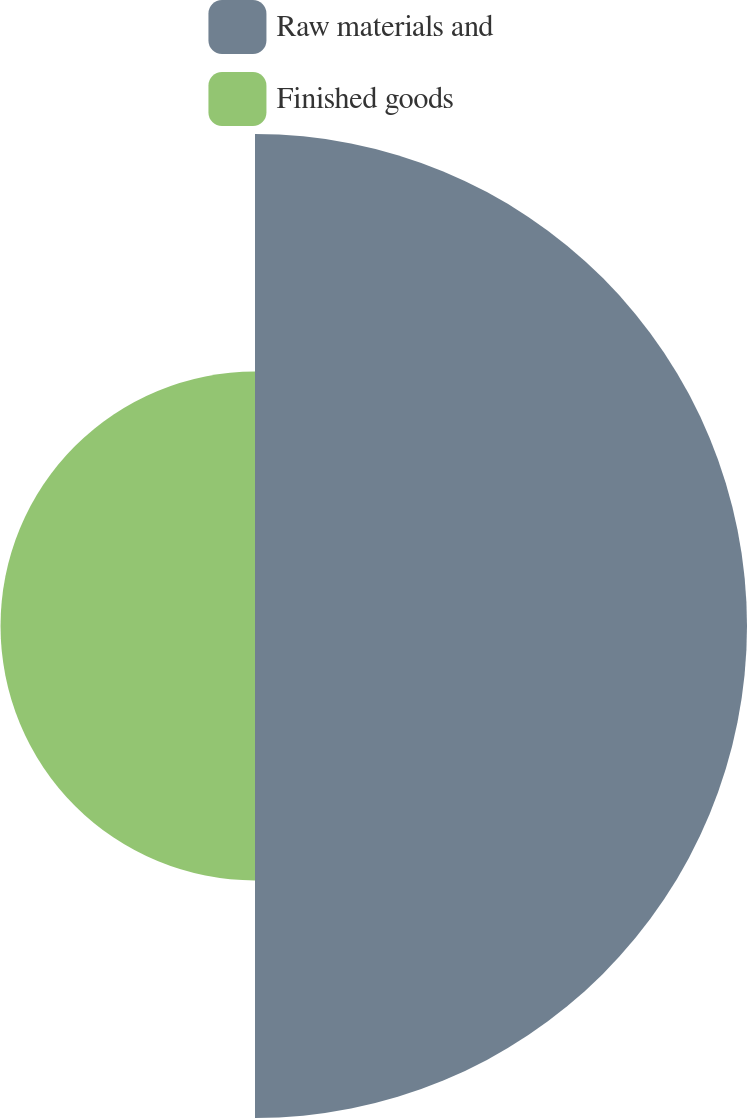<chart> <loc_0><loc_0><loc_500><loc_500><pie_chart><fcel>Raw materials and<fcel>Finished goods<nl><fcel>65.91%<fcel>34.09%<nl></chart> 